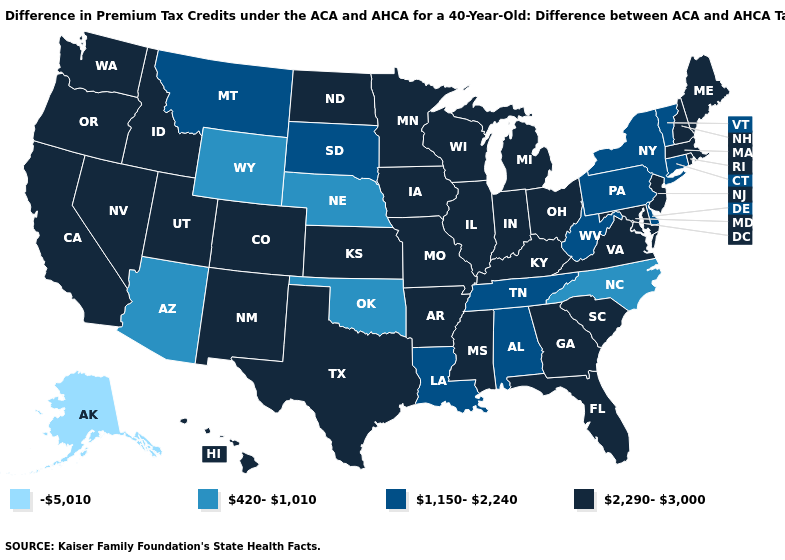Name the states that have a value in the range 420-1,010?
Be succinct. Arizona, Nebraska, North Carolina, Oklahoma, Wyoming. Does Pennsylvania have the highest value in the USA?
Short answer required. No. Does Hawaii have the highest value in the West?
Write a very short answer. Yes. What is the value of New Jersey?
Concise answer only. 2,290-3,000. What is the highest value in the USA?
Write a very short answer. 2,290-3,000. What is the lowest value in the USA?
Quick response, please. -5,010. How many symbols are there in the legend?
Answer briefly. 4. What is the value of Mississippi?
Give a very brief answer. 2,290-3,000. What is the value of South Carolina?
Concise answer only. 2,290-3,000. Does the map have missing data?
Answer briefly. No. Does New Hampshire have the lowest value in the Northeast?
Be succinct. No. What is the value of Oklahoma?
Concise answer only. 420-1,010. What is the value of Connecticut?
Short answer required. 1,150-2,240. Name the states that have a value in the range 1,150-2,240?
Be succinct. Alabama, Connecticut, Delaware, Louisiana, Montana, New York, Pennsylvania, South Dakota, Tennessee, Vermont, West Virginia. Name the states that have a value in the range 1,150-2,240?
Concise answer only. Alabama, Connecticut, Delaware, Louisiana, Montana, New York, Pennsylvania, South Dakota, Tennessee, Vermont, West Virginia. 